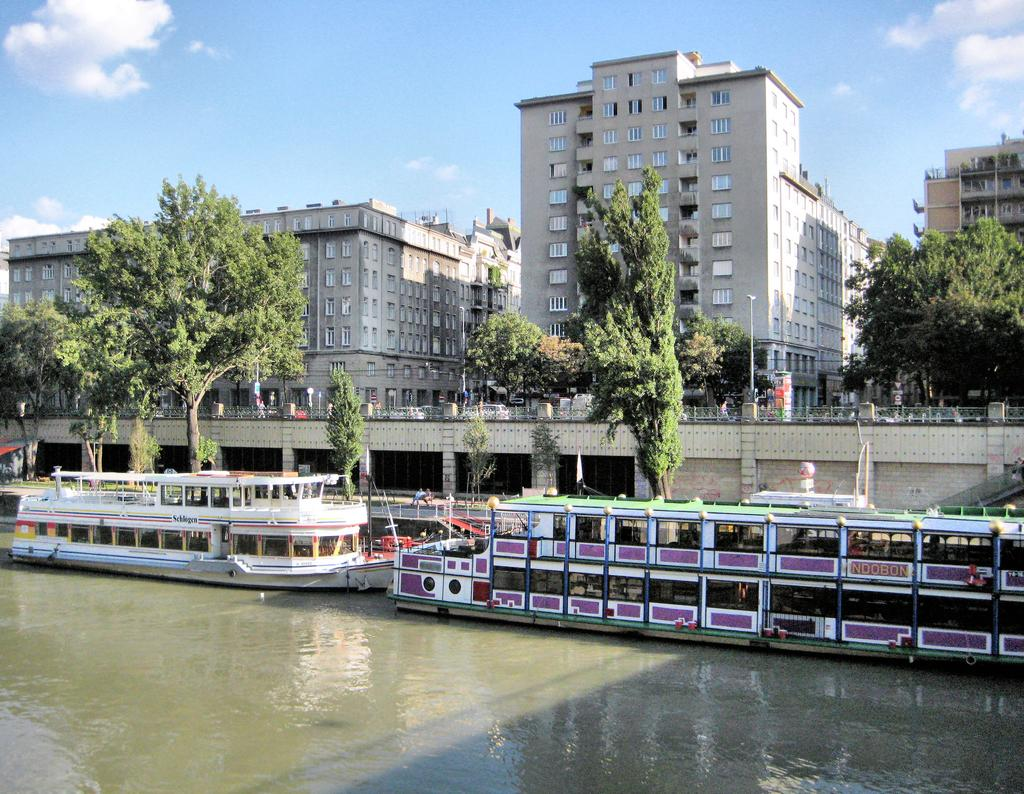What is located at the bottom of the image? There are boats at the bottom of the image. What can be seen in the image besides the boats? There is water, trees, a bridge, buildings, people, and poles visible in the image. What is the condition of the sky in the image? The sky is visible in the image, and there are clouds present. What is the price of the scale in the image? There is no scale present in the image, so it is not possible to determine its price. What year is depicted in the image? The image does not depict a specific year, as it is a general scene with no historical context. 